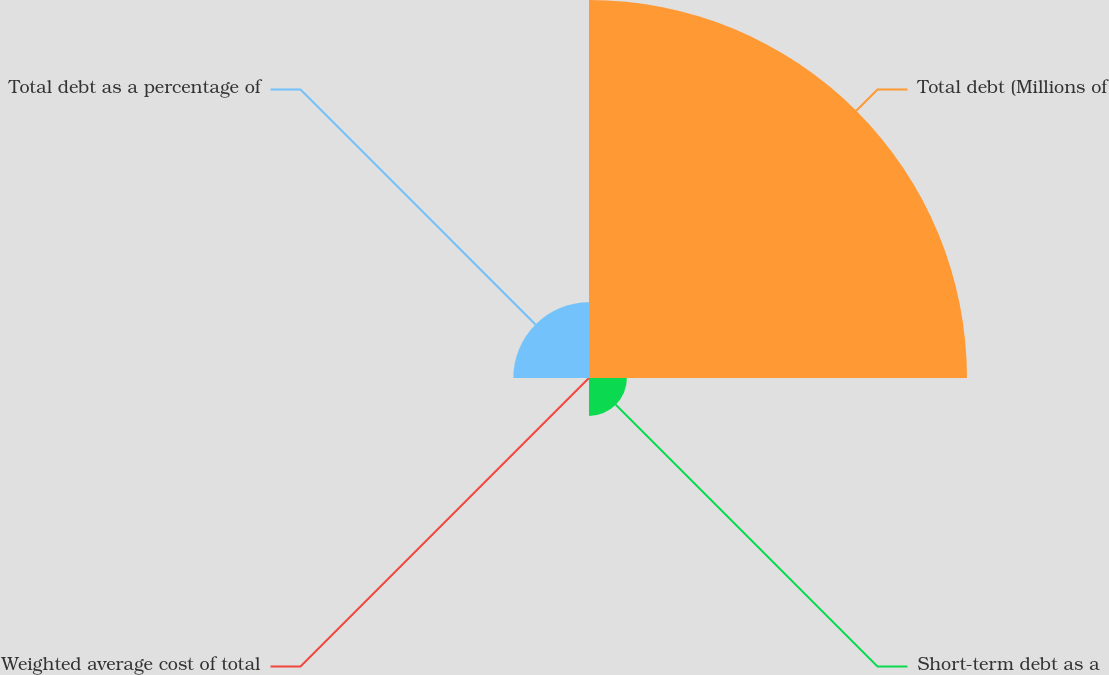Convert chart to OTSL. <chart><loc_0><loc_0><loc_500><loc_500><pie_chart><fcel>Total debt (Millions of<fcel>Short-term debt as a<fcel>Weighted average cost of total<fcel>Total debt as a percentage of<nl><fcel>76.88%<fcel>7.71%<fcel>0.02%<fcel>15.39%<nl></chart> 